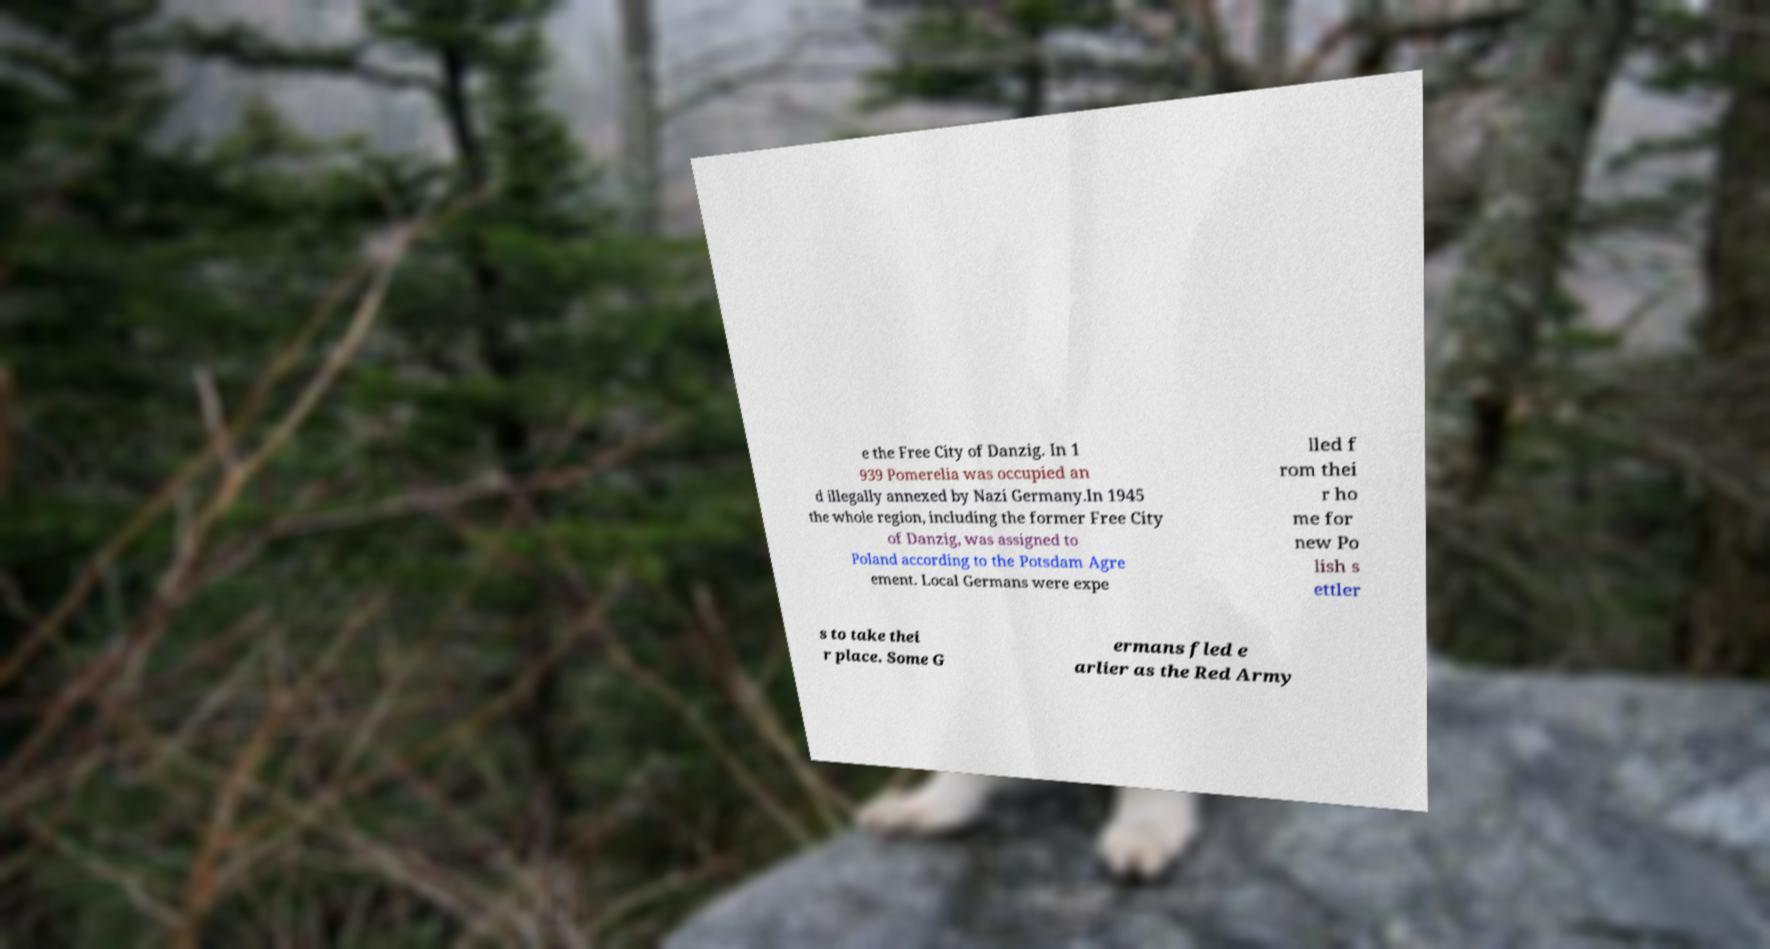Please read and relay the text visible in this image. What does it say? e the Free City of Danzig. In 1 939 Pomerelia was occupied an d illegally annexed by Nazi Germany.In 1945 the whole region, including the former Free City of Danzig, was assigned to Poland according to the Potsdam Agre ement. Local Germans were expe lled f rom thei r ho me for new Po lish s ettler s to take thei r place. Some G ermans fled e arlier as the Red Army 